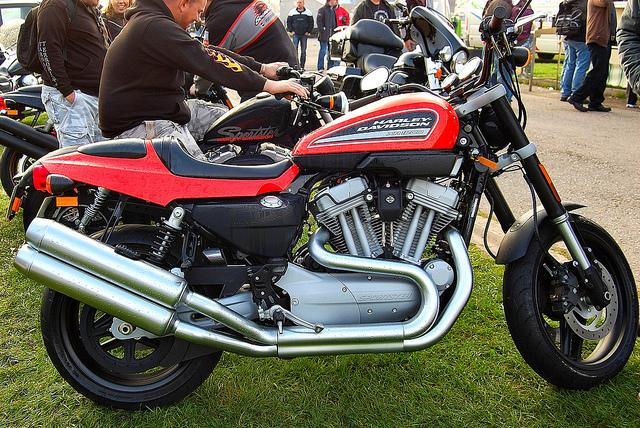What was the first name of Mr. Harley? Please explain your reasoning. william. William s. harley was one of the founders of this motorcycle company. 